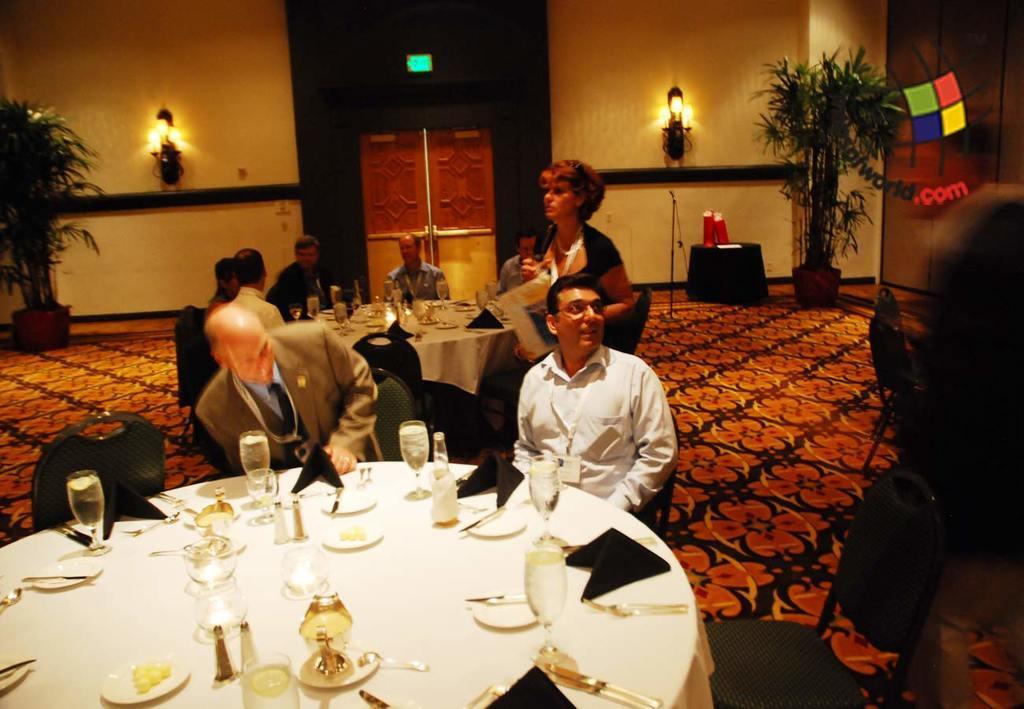Describe this image in one or two sentences. There are two men sitting in front of a table in the chairs. This is a dining table on which glass, cloth, plates, knives, forks are placed. There is a bottle on the table here. In the background there are some people sitting on another table same way. There is a one woman walking here. There is a carpet on the floor. There are lights attached to the background and some plants here. 